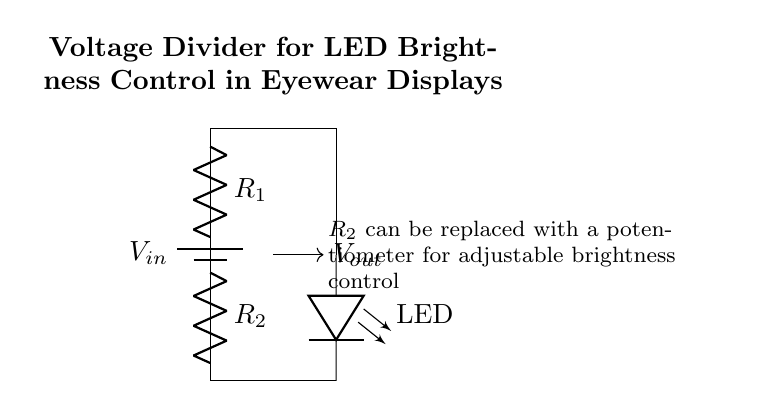what does R1 represent in the circuit? R1 is a resistor in the voltage divider circuit that is used to drop a portion of the input voltage.
Answer: resistor what is the role of R2 in this circuit? R2 is another resistor in the voltage divider that, along with R1, determines the output voltage that is applied to the LED.
Answer: resistor what is the purpose of the LED in the circuit? The LED serves as a light source that brightness can be controlled by adjusting the output voltage from the voltage divider.
Answer: light source what type of circuit is this? This is a voltage divider circuit specifically designed for controlling the brightness of an LED.
Answer: voltage divider how can the brightness control be adjusted? Brightness control can be adjusted by replacing R2 with a potentiometer, allowing variable resistance and therefore variable output voltage.
Answer: potentiometer what is the output voltage represented as? The output voltage is denoted as Vout, which is the voltage across R2 and the LED in this circuit arrangement.
Answer: Vout what happens if R1 is increased significantly? If R1 is increased significantly, the output voltage Vout will decrease, resulting in a dimmer LED.
Answer: dimmer LED 